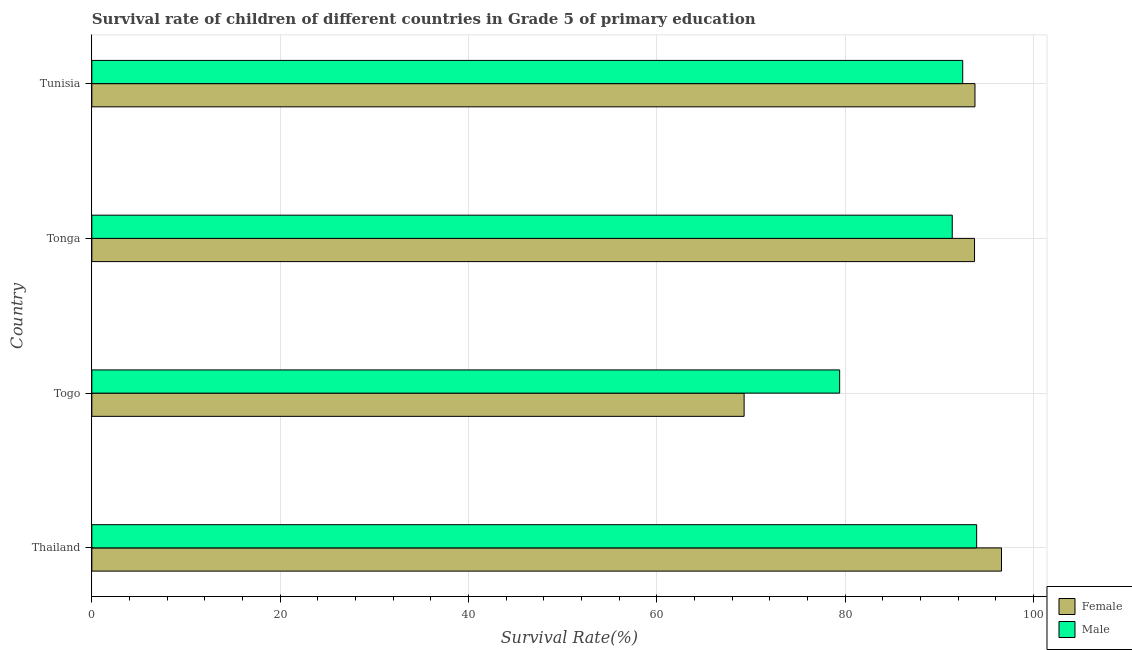How many different coloured bars are there?
Provide a short and direct response. 2. How many groups of bars are there?
Your response must be concise. 4. Are the number of bars on each tick of the Y-axis equal?
Ensure brevity in your answer.  Yes. How many bars are there on the 4th tick from the top?
Your answer should be compact. 2. What is the label of the 2nd group of bars from the top?
Ensure brevity in your answer.  Tonga. What is the survival rate of male students in primary education in Thailand?
Ensure brevity in your answer.  93.96. Across all countries, what is the maximum survival rate of male students in primary education?
Offer a terse response. 93.96. Across all countries, what is the minimum survival rate of male students in primary education?
Make the answer very short. 79.41. In which country was the survival rate of female students in primary education maximum?
Your answer should be compact. Thailand. In which country was the survival rate of female students in primary education minimum?
Your answer should be compact. Togo. What is the total survival rate of female students in primary education in the graph?
Offer a terse response. 353.36. What is the difference between the survival rate of male students in primary education in Togo and that in Tunisia?
Your response must be concise. -13.07. What is the difference between the survival rate of female students in primary education in Thailand and the survival rate of male students in primary education in Tonga?
Your answer should be very brief. 5.23. What is the average survival rate of male students in primary education per country?
Keep it short and to the point. 89.3. What is the difference between the survival rate of male students in primary education and survival rate of female students in primary education in Tunisia?
Offer a very short reply. -1.3. What is the ratio of the survival rate of female students in primary education in Thailand to that in Togo?
Offer a very short reply. 1.4. Is the difference between the survival rate of male students in primary education in Thailand and Tonga greater than the difference between the survival rate of female students in primary education in Thailand and Tonga?
Provide a succinct answer. No. What is the difference between the highest and the second highest survival rate of female students in primary education?
Your answer should be very brief. 2.82. What is the difference between the highest and the lowest survival rate of female students in primary education?
Your answer should be compact. 27.33. Is the sum of the survival rate of female students in primary education in Thailand and Togo greater than the maximum survival rate of male students in primary education across all countries?
Provide a short and direct response. Yes. What does the 1st bar from the bottom in Tunisia represents?
Your answer should be compact. Female. How many bars are there?
Keep it short and to the point. 8. Does the graph contain any zero values?
Provide a succinct answer. No. What is the title of the graph?
Give a very brief answer. Survival rate of children of different countries in Grade 5 of primary education. What is the label or title of the X-axis?
Make the answer very short. Survival Rate(%). What is the label or title of the Y-axis?
Provide a short and direct response. Country. What is the Survival Rate(%) of Female in Thailand?
Provide a short and direct response. 96.59. What is the Survival Rate(%) of Male in Thailand?
Offer a very short reply. 93.96. What is the Survival Rate(%) of Female in Togo?
Offer a terse response. 69.26. What is the Survival Rate(%) in Male in Togo?
Provide a succinct answer. 79.41. What is the Survival Rate(%) of Female in Tonga?
Offer a very short reply. 93.73. What is the Survival Rate(%) of Male in Tonga?
Provide a succinct answer. 91.36. What is the Survival Rate(%) of Female in Tunisia?
Provide a short and direct response. 93.78. What is the Survival Rate(%) of Male in Tunisia?
Ensure brevity in your answer.  92.48. Across all countries, what is the maximum Survival Rate(%) in Female?
Your response must be concise. 96.59. Across all countries, what is the maximum Survival Rate(%) of Male?
Ensure brevity in your answer.  93.96. Across all countries, what is the minimum Survival Rate(%) in Female?
Your answer should be very brief. 69.26. Across all countries, what is the minimum Survival Rate(%) in Male?
Your response must be concise. 79.41. What is the total Survival Rate(%) of Female in the graph?
Your answer should be very brief. 353.36. What is the total Survival Rate(%) of Male in the graph?
Keep it short and to the point. 357.2. What is the difference between the Survival Rate(%) in Female in Thailand and that in Togo?
Give a very brief answer. 27.33. What is the difference between the Survival Rate(%) of Male in Thailand and that in Togo?
Make the answer very short. 14.55. What is the difference between the Survival Rate(%) in Female in Thailand and that in Tonga?
Provide a succinct answer. 2.86. What is the difference between the Survival Rate(%) in Male in Thailand and that in Tonga?
Your answer should be very brief. 2.59. What is the difference between the Survival Rate(%) in Female in Thailand and that in Tunisia?
Offer a terse response. 2.82. What is the difference between the Survival Rate(%) of Male in Thailand and that in Tunisia?
Your response must be concise. 1.48. What is the difference between the Survival Rate(%) of Female in Togo and that in Tonga?
Give a very brief answer. -24.47. What is the difference between the Survival Rate(%) of Male in Togo and that in Tonga?
Provide a succinct answer. -11.96. What is the difference between the Survival Rate(%) in Female in Togo and that in Tunisia?
Ensure brevity in your answer.  -24.51. What is the difference between the Survival Rate(%) of Male in Togo and that in Tunisia?
Keep it short and to the point. -13.07. What is the difference between the Survival Rate(%) of Female in Tonga and that in Tunisia?
Offer a very short reply. -0.05. What is the difference between the Survival Rate(%) of Male in Tonga and that in Tunisia?
Keep it short and to the point. -1.11. What is the difference between the Survival Rate(%) in Female in Thailand and the Survival Rate(%) in Male in Togo?
Ensure brevity in your answer.  17.19. What is the difference between the Survival Rate(%) in Female in Thailand and the Survival Rate(%) in Male in Tonga?
Offer a very short reply. 5.23. What is the difference between the Survival Rate(%) in Female in Thailand and the Survival Rate(%) in Male in Tunisia?
Keep it short and to the point. 4.12. What is the difference between the Survival Rate(%) of Female in Togo and the Survival Rate(%) of Male in Tonga?
Provide a succinct answer. -22.1. What is the difference between the Survival Rate(%) of Female in Togo and the Survival Rate(%) of Male in Tunisia?
Offer a very short reply. -23.21. What is the difference between the Survival Rate(%) of Female in Tonga and the Survival Rate(%) of Male in Tunisia?
Offer a terse response. 1.25. What is the average Survival Rate(%) of Female per country?
Provide a succinct answer. 88.34. What is the average Survival Rate(%) of Male per country?
Offer a terse response. 89.3. What is the difference between the Survival Rate(%) of Female and Survival Rate(%) of Male in Thailand?
Your answer should be very brief. 2.64. What is the difference between the Survival Rate(%) of Female and Survival Rate(%) of Male in Togo?
Make the answer very short. -10.14. What is the difference between the Survival Rate(%) in Female and Survival Rate(%) in Male in Tonga?
Ensure brevity in your answer.  2.37. What is the difference between the Survival Rate(%) in Female and Survival Rate(%) in Male in Tunisia?
Offer a very short reply. 1.3. What is the ratio of the Survival Rate(%) in Female in Thailand to that in Togo?
Make the answer very short. 1.39. What is the ratio of the Survival Rate(%) in Male in Thailand to that in Togo?
Your answer should be compact. 1.18. What is the ratio of the Survival Rate(%) in Female in Thailand to that in Tonga?
Keep it short and to the point. 1.03. What is the ratio of the Survival Rate(%) in Male in Thailand to that in Tonga?
Give a very brief answer. 1.03. What is the ratio of the Survival Rate(%) in Male in Thailand to that in Tunisia?
Keep it short and to the point. 1.02. What is the ratio of the Survival Rate(%) of Female in Togo to that in Tonga?
Ensure brevity in your answer.  0.74. What is the ratio of the Survival Rate(%) of Male in Togo to that in Tonga?
Your answer should be compact. 0.87. What is the ratio of the Survival Rate(%) of Female in Togo to that in Tunisia?
Offer a terse response. 0.74. What is the ratio of the Survival Rate(%) of Male in Togo to that in Tunisia?
Ensure brevity in your answer.  0.86. What is the ratio of the Survival Rate(%) in Female in Tonga to that in Tunisia?
Provide a succinct answer. 1. What is the ratio of the Survival Rate(%) of Male in Tonga to that in Tunisia?
Provide a short and direct response. 0.99. What is the difference between the highest and the second highest Survival Rate(%) in Female?
Offer a terse response. 2.82. What is the difference between the highest and the second highest Survival Rate(%) in Male?
Offer a very short reply. 1.48. What is the difference between the highest and the lowest Survival Rate(%) in Female?
Your response must be concise. 27.33. What is the difference between the highest and the lowest Survival Rate(%) of Male?
Your answer should be compact. 14.55. 